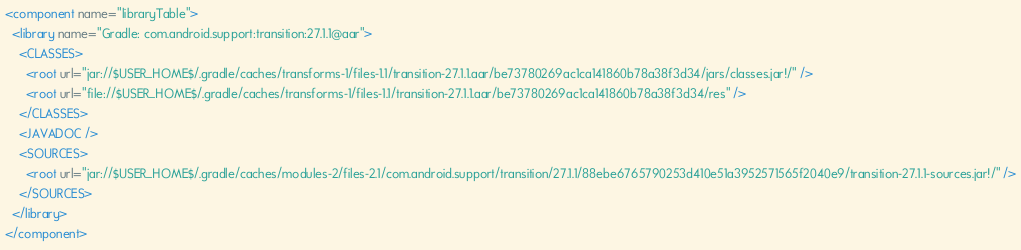Convert code to text. <code><loc_0><loc_0><loc_500><loc_500><_XML_><component name="libraryTable">
  <library name="Gradle: com.android.support:transition:27.1.1@aar">
    <CLASSES>
      <root url="jar://$USER_HOME$/.gradle/caches/transforms-1/files-1.1/transition-27.1.1.aar/be73780269ac1ca141860b78a38f3d34/jars/classes.jar!/" />
      <root url="file://$USER_HOME$/.gradle/caches/transforms-1/files-1.1/transition-27.1.1.aar/be73780269ac1ca141860b78a38f3d34/res" />
    </CLASSES>
    <JAVADOC />
    <SOURCES>
      <root url="jar://$USER_HOME$/.gradle/caches/modules-2/files-2.1/com.android.support/transition/27.1.1/88ebe6765790253d410e51a3952571565f2040e9/transition-27.1.1-sources.jar!/" />
    </SOURCES>
  </library>
</component></code> 